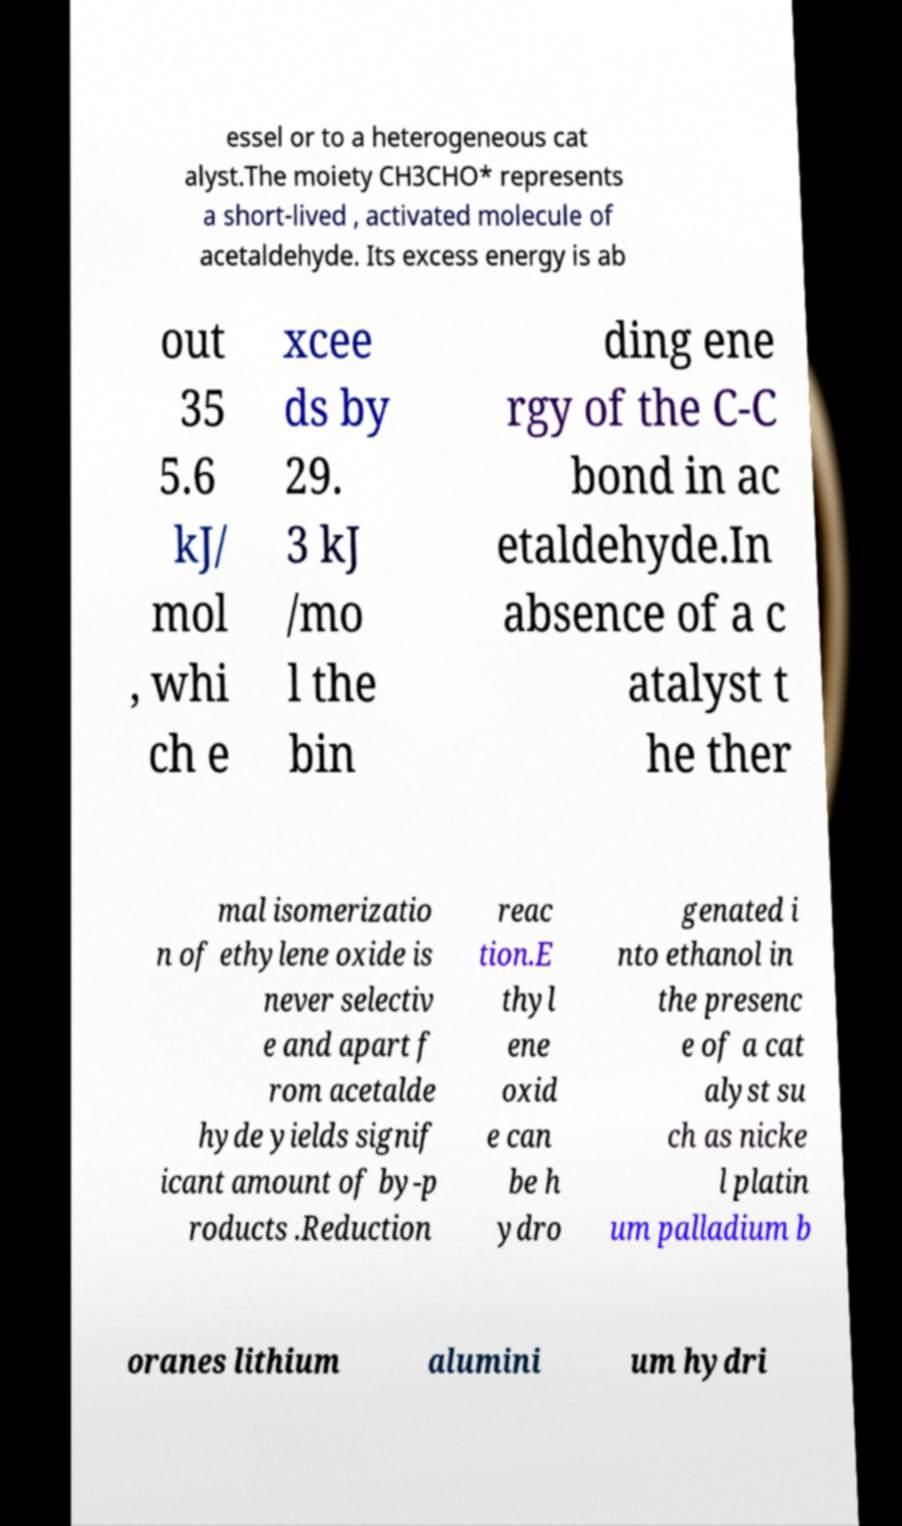There's text embedded in this image that I need extracted. Can you transcribe it verbatim? essel or to a heterogeneous cat alyst.The moiety CH3CHO* represents a short-lived , activated molecule of acetaldehyde. Its excess energy is ab out 35 5.6 kJ/ mol , whi ch e xcee ds by 29. 3 kJ /mo l the bin ding ene rgy of the C-C bond in ac etaldehyde.In absence of a c atalyst t he ther mal isomerizatio n of ethylene oxide is never selectiv e and apart f rom acetalde hyde yields signif icant amount of by-p roducts .Reduction reac tion.E thyl ene oxid e can be h ydro genated i nto ethanol in the presenc e of a cat alyst su ch as nicke l platin um palladium b oranes lithium alumini um hydri 